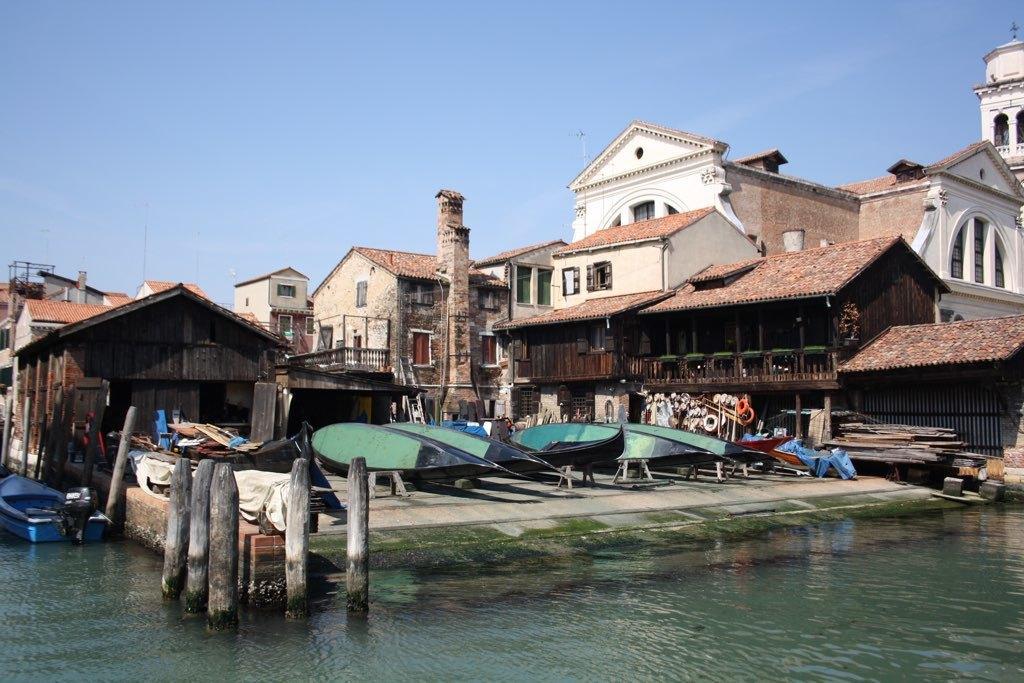Can you describe this image briefly? At the bottom of the image there is water. There are poles in the water and also there is a boat on the water. Behind the water there are few boats. In the background there are many buildings with walls, windows, pillars, roofs and railings. At the top of the image there is a sky. And also there are few wooden items on the floor. 